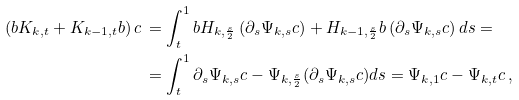<formula> <loc_0><loc_0><loc_500><loc_500>\left ( b K _ { k , t } + K _ { k - 1 , t } b \right ) c \, & = \int _ { t } ^ { 1 } b H _ { k , \frac { s } { 2 } } \left ( \partial _ { s } \Psi _ { k , s } c \right ) + H _ { k - 1 , \frac { s } { 2 } } b \left ( \partial _ { s } \Psi _ { k , s } c \right ) d s = \\ & = \int _ { t } ^ { 1 } \partial _ { s } \Psi _ { k , s } c - \Psi _ { k , \frac { s } { 2 } } ( \partial _ { s } \Psi _ { k , s } c ) d s = \Psi _ { k , 1 } c - \Psi _ { k , t } c \, ,</formula> 